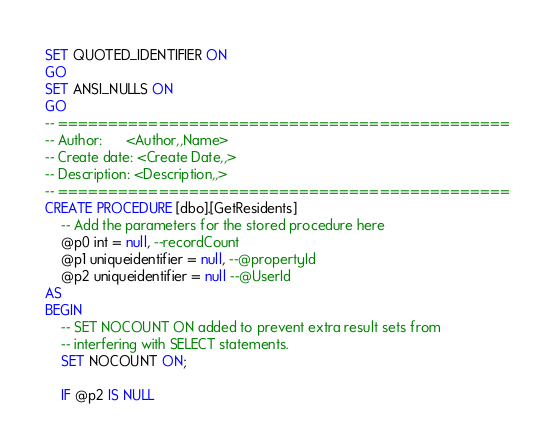<code> <loc_0><loc_0><loc_500><loc_500><_SQL_>SET QUOTED_IDENTIFIER ON
GO
SET ANSI_NULLS ON
GO
-- =============================================
-- Author:		<Author,,Name>
-- Create date: <Create Date,,>
-- Description:	<Description,,>
-- =============================================
CREATE PROCEDURE [dbo].[GetResidents]
	-- Add the parameters for the stored procedure here
	@p0 int = null, --recordCount
	@p1 uniqueidentifier = null, --@propertyId
	@p2 uniqueidentifier = null --@UserId
AS
BEGIN
	-- SET NOCOUNT ON added to prevent extra result sets from
	-- interfering with SELECT statements.
	SET NOCOUNT ON;

	IF @p2 IS NULL</code> 